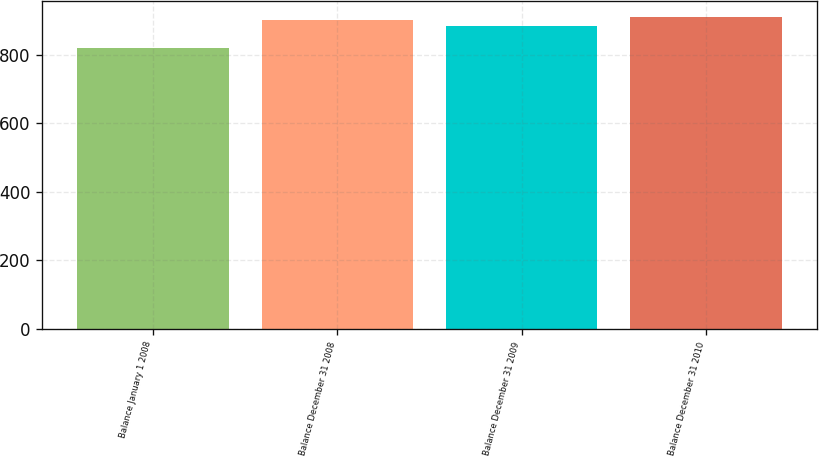Convert chart. <chart><loc_0><loc_0><loc_500><loc_500><bar_chart><fcel>Balance January 1 2008<fcel>Balance December 31 2008<fcel>Balance December 31 2009<fcel>Balance December 31 2010<nl><fcel>821<fcel>903<fcel>886<fcel>912.1<nl></chart> 